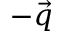Convert formula to latex. <formula><loc_0><loc_0><loc_500><loc_500>- \vec { q }</formula> 